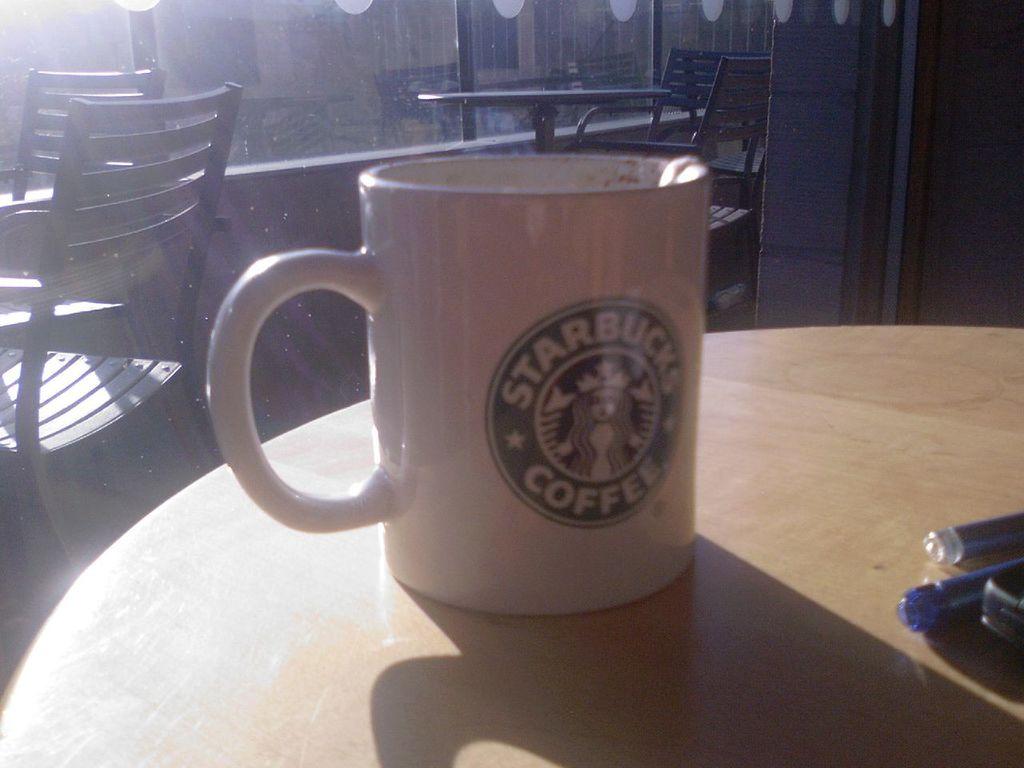Where is the mug from?
Provide a succinct answer. Starbucks. What does starbucks sell?
Ensure brevity in your answer.  Coffee. 